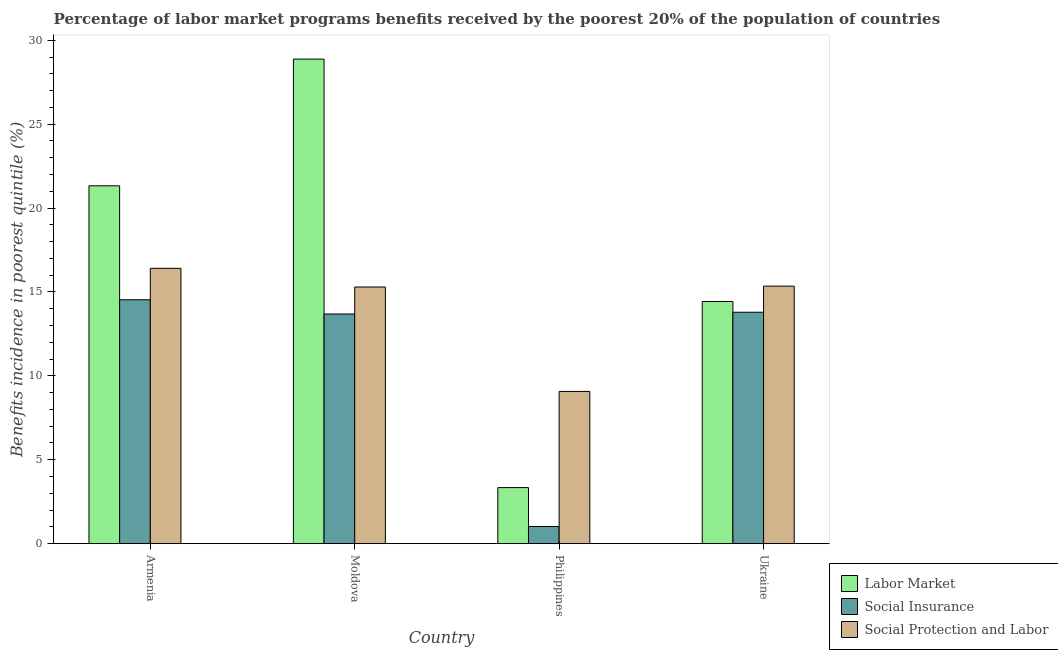How many different coloured bars are there?
Offer a very short reply. 3. How many groups of bars are there?
Your response must be concise. 4. How many bars are there on the 4th tick from the right?
Make the answer very short. 3. What is the label of the 4th group of bars from the left?
Offer a terse response. Ukraine. What is the percentage of benefits received due to social insurance programs in Ukraine?
Give a very brief answer. 13.79. Across all countries, what is the maximum percentage of benefits received due to social protection programs?
Your response must be concise. 16.41. Across all countries, what is the minimum percentage of benefits received due to labor market programs?
Keep it short and to the point. 3.34. In which country was the percentage of benefits received due to social protection programs maximum?
Your response must be concise. Armenia. In which country was the percentage of benefits received due to labor market programs minimum?
Your answer should be very brief. Philippines. What is the total percentage of benefits received due to social insurance programs in the graph?
Make the answer very short. 43.03. What is the difference between the percentage of benefits received due to social protection programs in Philippines and that in Ukraine?
Provide a short and direct response. -6.28. What is the difference between the percentage of benefits received due to labor market programs in Philippines and the percentage of benefits received due to social insurance programs in Armenia?
Give a very brief answer. -11.19. What is the average percentage of benefits received due to social insurance programs per country?
Provide a succinct answer. 10.76. What is the difference between the percentage of benefits received due to labor market programs and percentage of benefits received due to social insurance programs in Ukraine?
Your response must be concise. 0.64. What is the ratio of the percentage of benefits received due to social insurance programs in Armenia to that in Moldova?
Provide a short and direct response. 1.06. Is the percentage of benefits received due to social protection programs in Moldova less than that in Ukraine?
Offer a terse response. Yes. What is the difference between the highest and the second highest percentage of benefits received due to social protection programs?
Offer a very short reply. 1.06. What is the difference between the highest and the lowest percentage of benefits received due to labor market programs?
Ensure brevity in your answer.  25.54. In how many countries, is the percentage of benefits received due to social protection programs greater than the average percentage of benefits received due to social protection programs taken over all countries?
Your response must be concise. 3. What does the 3rd bar from the left in Armenia represents?
Offer a terse response. Social Protection and Labor. What does the 1st bar from the right in Armenia represents?
Provide a short and direct response. Social Protection and Labor. How many countries are there in the graph?
Your answer should be compact. 4. What is the difference between two consecutive major ticks on the Y-axis?
Offer a very short reply. 5. Where does the legend appear in the graph?
Provide a succinct answer. Bottom right. How are the legend labels stacked?
Give a very brief answer. Vertical. What is the title of the graph?
Your answer should be very brief. Percentage of labor market programs benefits received by the poorest 20% of the population of countries. What is the label or title of the Y-axis?
Your answer should be very brief. Benefits incidence in poorest quintile (%). What is the Benefits incidence in poorest quintile (%) of Labor Market in Armenia?
Make the answer very short. 21.33. What is the Benefits incidence in poorest quintile (%) in Social Insurance in Armenia?
Your response must be concise. 14.54. What is the Benefits incidence in poorest quintile (%) of Social Protection and Labor in Armenia?
Provide a succinct answer. 16.41. What is the Benefits incidence in poorest quintile (%) in Labor Market in Moldova?
Your response must be concise. 28.88. What is the Benefits incidence in poorest quintile (%) in Social Insurance in Moldova?
Your response must be concise. 13.69. What is the Benefits incidence in poorest quintile (%) of Social Protection and Labor in Moldova?
Offer a very short reply. 15.29. What is the Benefits incidence in poorest quintile (%) in Labor Market in Philippines?
Ensure brevity in your answer.  3.34. What is the Benefits incidence in poorest quintile (%) of Social Insurance in Philippines?
Your answer should be compact. 1.02. What is the Benefits incidence in poorest quintile (%) of Social Protection and Labor in Philippines?
Your answer should be very brief. 9.07. What is the Benefits incidence in poorest quintile (%) of Labor Market in Ukraine?
Give a very brief answer. 14.43. What is the Benefits incidence in poorest quintile (%) in Social Insurance in Ukraine?
Offer a very short reply. 13.79. What is the Benefits incidence in poorest quintile (%) of Social Protection and Labor in Ukraine?
Make the answer very short. 15.35. Across all countries, what is the maximum Benefits incidence in poorest quintile (%) in Labor Market?
Provide a short and direct response. 28.88. Across all countries, what is the maximum Benefits incidence in poorest quintile (%) in Social Insurance?
Offer a very short reply. 14.54. Across all countries, what is the maximum Benefits incidence in poorest quintile (%) of Social Protection and Labor?
Your answer should be very brief. 16.41. Across all countries, what is the minimum Benefits incidence in poorest quintile (%) in Labor Market?
Your answer should be compact. 3.34. Across all countries, what is the minimum Benefits incidence in poorest quintile (%) of Social Insurance?
Your answer should be very brief. 1.02. Across all countries, what is the minimum Benefits incidence in poorest quintile (%) of Social Protection and Labor?
Offer a very short reply. 9.07. What is the total Benefits incidence in poorest quintile (%) in Labor Market in the graph?
Give a very brief answer. 67.97. What is the total Benefits incidence in poorest quintile (%) in Social Insurance in the graph?
Provide a short and direct response. 43.03. What is the total Benefits incidence in poorest quintile (%) in Social Protection and Labor in the graph?
Give a very brief answer. 56.12. What is the difference between the Benefits incidence in poorest quintile (%) of Labor Market in Armenia and that in Moldova?
Ensure brevity in your answer.  -7.55. What is the difference between the Benefits incidence in poorest quintile (%) in Social Insurance in Armenia and that in Moldova?
Offer a very short reply. 0.85. What is the difference between the Benefits incidence in poorest quintile (%) in Social Protection and Labor in Armenia and that in Moldova?
Make the answer very short. 1.11. What is the difference between the Benefits incidence in poorest quintile (%) of Labor Market in Armenia and that in Philippines?
Offer a very short reply. 17.99. What is the difference between the Benefits incidence in poorest quintile (%) of Social Insurance in Armenia and that in Philippines?
Offer a terse response. 13.51. What is the difference between the Benefits incidence in poorest quintile (%) of Social Protection and Labor in Armenia and that in Philippines?
Provide a succinct answer. 7.34. What is the difference between the Benefits incidence in poorest quintile (%) in Labor Market in Armenia and that in Ukraine?
Your answer should be compact. 6.89. What is the difference between the Benefits incidence in poorest quintile (%) of Social Insurance in Armenia and that in Ukraine?
Keep it short and to the point. 0.74. What is the difference between the Benefits incidence in poorest quintile (%) in Social Protection and Labor in Armenia and that in Ukraine?
Offer a terse response. 1.06. What is the difference between the Benefits incidence in poorest quintile (%) of Labor Market in Moldova and that in Philippines?
Your answer should be very brief. 25.54. What is the difference between the Benefits incidence in poorest quintile (%) of Social Insurance in Moldova and that in Philippines?
Provide a succinct answer. 12.66. What is the difference between the Benefits incidence in poorest quintile (%) of Social Protection and Labor in Moldova and that in Philippines?
Your answer should be very brief. 6.22. What is the difference between the Benefits incidence in poorest quintile (%) of Labor Market in Moldova and that in Ukraine?
Provide a succinct answer. 14.44. What is the difference between the Benefits incidence in poorest quintile (%) in Social Insurance in Moldova and that in Ukraine?
Your response must be concise. -0.1. What is the difference between the Benefits incidence in poorest quintile (%) of Social Protection and Labor in Moldova and that in Ukraine?
Ensure brevity in your answer.  -0.05. What is the difference between the Benefits incidence in poorest quintile (%) of Labor Market in Philippines and that in Ukraine?
Keep it short and to the point. -11.09. What is the difference between the Benefits incidence in poorest quintile (%) of Social Insurance in Philippines and that in Ukraine?
Your answer should be compact. -12.77. What is the difference between the Benefits incidence in poorest quintile (%) in Social Protection and Labor in Philippines and that in Ukraine?
Your response must be concise. -6.28. What is the difference between the Benefits incidence in poorest quintile (%) of Labor Market in Armenia and the Benefits incidence in poorest quintile (%) of Social Insurance in Moldova?
Provide a short and direct response. 7.64. What is the difference between the Benefits incidence in poorest quintile (%) in Labor Market in Armenia and the Benefits incidence in poorest quintile (%) in Social Protection and Labor in Moldova?
Your response must be concise. 6.03. What is the difference between the Benefits incidence in poorest quintile (%) of Social Insurance in Armenia and the Benefits incidence in poorest quintile (%) of Social Protection and Labor in Moldova?
Offer a very short reply. -0.76. What is the difference between the Benefits incidence in poorest quintile (%) in Labor Market in Armenia and the Benefits incidence in poorest quintile (%) in Social Insurance in Philippines?
Provide a short and direct response. 20.3. What is the difference between the Benefits incidence in poorest quintile (%) in Labor Market in Armenia and the Benefits incidence in poorest quintile (%) in Social Protection and Labor in Philippines?
Offer a terse response. 12.25. What is the difference between the Benefits incidence in poorest quintile (%) of Social Insurance in Armenia and the Benefits incidence in poorest quintile (%) of Social Protection and Labor in Philippines?
Your response must be concise. 5.46. What is the difference between the Benefits incidence in poorest quintile (%) in Labor Market in Armenia and the Benefits incidence in poorest quintile (%) in Social Insurance in Ukraine?
Give a very brief answer. 7.53. What is the difference between the Benefits incidence in poorest quintile (%) in Labor Market in Armenia and the Benefits incidence in poorest quintile (%) in Social Protection and Labor in Ukraine?
Keep it short and to the point. 5.98. What is the difference between the Benefits incidence in poorest quintile (%) in Social Insurance in Armenia and the Benefits incidence in poorest quintile (%) in Social Protection and Labor in Ukraine?
Give a very brief answer. -0.81. What is the difference between the Benefits incidence in poorest quintile (%) of Labor Market in Moldova and the Benefits incidence in poorest quintile (%) of Social Insurance in Philippines?
Ensure brevity in your answer.  27.85. What is the difference between the Benefits incidence in poorest quintile (%) of Labor Market in Moldova and the Benefits incidence in poorest quintile (%) of Social Protection and Labor in Philippines?
Your response must be concise. 19.8. What is the difference between the Benefits incidence in poorest quintile (%) in Social Insurance in Moldova and the Benefits incidence in poorest quintile (%) in Social Protection and Labor in Philippines?
Your answer should be very brief. 4.62. What is the difference between the Benefits incidence in poorest quintile (%) of Labor Market in Moldova and the Benefits incidence in poorest quintile (%) of Social Insurance in Ukraine?
Ensure brevity in your answer.  15.09. What is the difference between the Benefits incidence in poorest quintile (%) of Labor Market in Moldova and the Benefits incidence in poorest quintile (%) of Social Protection and Labor in Ukraine?
Provide a succinct answer. 13.53. What is the difference between the Benefits incidence in poorest quintile (%) of Social Insurance in Moldova and the Benefits incidence in poorest quintile (%) of Social Protection and Labor in Ukraine?
Offer a terse response. -1.66. What is the difference between the Benefits incidence in poorest quintile (%) of Labor Market in Philippines and the Benefits incidence in poorest quintile (%) of Social Insurance in Ukraine?
Keep it short and to the point. -10.45. What is the difference between the Benefits incidence in poorest quintile (%) in Labor Market in Philippines and the Benefits incidence in poorest quintile (%) in Social Protection and Labor in Ukraine?
Provide a succinct answer. -12.01. What is the difference between the Benefits incidence in poorest quintile (%) of Social Insurance in Philippines and the Benefits incidence in poorest quintile (%) of Social Protection and Labor in Ukraine?
Offer a very short reply. -14.32. What is the average Benefits incidence in poorest quintile (%) of Labor Market per country?
Your answer should be compact. 16.99. What is the average Benefits incidence in poorest quintile (%) in Social Insurance per country?
Your response must be concise. 10.76. What is the average Benefits incidence in poorest quintile (%) in Social Protection and Labor per country?
Your response must be concise. 14.03. What is the difference between the Benefits incidence in poorest quintile (%) in Labor Market and Benefits incidence in poorest quintile (%) in Social Insurance in Armenia?
Your answer should be very brief. 6.79. What is the difference between the Benefits incidence in poorest quintile (%) of Labor Market and Benefits incidence in poorest quintile (%) of Social Protection and Labor in Armenia?
Provide a succinct answer. 4.92. What is the difference between the Benefits incidence in poorest quintile (%) in Social Insurance and Benefits incidence in poorest quintile (%) in Social Protection and Labor in Armenia?
Give a very brief answer. -1.87. What is the difference between the Benefits incidence in poorest quintile (%) of Labor Market and Benefits incidence in poorest quintile (%) of Social Insurance in Moldova?
Offer a very short reply. 15.19. What is the difference between the Benefits incidence in poorest quintile (%) in Labor Market and Benefits incidence in poorest quintile (%) in Social Protection and Labor in Moldova?
Your answer should be very brief. 13.58. What is the difference between the Benefits incidence in poorest quintile (%) in Social Insurance and Benefits incidence in poorest quintile (%) in Social Protection and Labor in Moldova?
Your answer should be compact. -1.61. What is the difference between the Benefits incidence in poorest quintile (%) in Labor Market and Benefits incidence in poorest quintile (%) in Social Insurance in Philippines?
Make the answer very short. 2.32. What is the difference between the Benefits incidence in poorest quintile (%) in Labor Market and Benefits incidence in poorest quintile (%) in Social Protection and Labor in Philippines?
Your response must be concise. -5.73. What is the difference between the Benefits incidence in poorest quintile (%) in Social Insurance and Benefits incidence in poorest quintile (%) in Social Protection and Labor in Philippines?
Your answer should be very brief. -8.05. What is the difference between the Benefits incidence in poorest quintile (%) of Labor Market and Benefits incidence in poorest quintile (%) of Social Insurance in Ukraine?
Make the answer very short. 0.64. What is the difference between the Benefits incidence in poorest quintile (%) in Labor Market and Benefits incidence in poorest quintile (%) in Social Protection and Labor in Ukraine?
Provide a succinct answer. -0.91. What is the difference between the Benefits incidence in poorest quintile (%) of Social Insurance and Benefits incidence in poorest quintile (%) of Social Protection and Labor in Ukraine?
Offer a terse response. -1.56. What is the ratio of the Benefits incidence in poorest quintile (%) in Labor Market in Armenia to that in Moldova?
Your answer should be compact. 0.74. What is the ratio of the Benefits incidence in poorest quintile (%) of Social Insurance in Armenia to that in Moldova?
Provide a short and direct response. 1.06. What is the ratio of the Benefits incidence in poorest quintile (%) in Social Protection and Labor in Armenia to that in Moldova?
Make the answer very short. 1.07. What is the ratio of the Benefits incidence in poorest quintile (%) of Labor Market in Armenia to that in Philippines?
Provide a succinct answer. 6.38. What is the ratio of the Benefits incidence in poorest quintile (%) of Social Insurance in Armenia to that in Philippines?
Ensure brevity in your answer.  14.22. What is the ratio of the Benefits incidence in poorest quintile (%) of Social Protection and Labor in Armenia to that in Philippines?
Ensure brevity in your answer.  1.81. What is the ratio of the Benefits incidence in poorest quintile (%) in Labor Market in Armenia to that in Ukraine?
Your answer should be very brief. 1.48. What is the ratio of the Benefits incidence in poorest quintile (%) in Social Insurance in Armenia to that in Ukraine?
Offer a terse response. 1.05. What is the ratio of the Benefits incidence in poorest quintile (%) of Social Protection and Labor in Armenia to that in Ukraine?
Keep it short and to the point. 1.07. What is the ratio of the Benefits incidence in poorest quintile (%) of Labor Market in Moldova to that in Philippines?
Provide a succinct answer. 8.64. What is the ratio of the Benefits incidence in poorest quintile (%) in Social Insurance in Moldova to that in Philippines?
Offer a very short reply. 13.39. What is the ratio of the Benefits incidence in poorest quintile (%) of Social Protection and Labor in Moldova to that in Philippines?
Make the answer very short. 1.69. What is the ratio of the Benefits incidence in poorest quintile (%) in Labor Market in Moldova to that in Ukraine?
Offer a very short reply. 2. What is the ratio of the Benefits incidence in poorest quintile (%) of Social Insurance in Moldova to that in Ukraine?
Offer a very short reply. 0.99. What is the ratio of the Benefits incidence in poorest quintile (%) of Social Protection and Labor in Moldova to that in Ukraine?
Offer a very short reply. 1. What is the ratio of the Benefits incidence in poorest quintile (%) of Labor Market in Philippines to that in Ukraine?
Keep it short and to the point. 0.23. What is the ratio of the Benefits incidence in poorest quintile (%) of Social Insurance in Philippines to that in Ukraine?
Give a very brief answer. 0.07. What is the ratio of the Benefits incidence in poorest quintile (%) in Social Protection and Labor in Philippines to that in Ukraine?
Keep it short and to the point. 0.59. What is the difference between the highest and the second highest Benefits incidence in poorest quintile (%) in Labor Market?
Provide a short and direct response. 7.55. What is the difference between the highest and the second highest Benefits incidence in poorest quintile (%) of Social Insurance?
Your response must be concise. 0.74. What is the difference between the highest and the second highest Benefits incidence in poorest quintile (%) of Social Protection and Labor?
Give a very brief answer. 1.06. What is the difference between the highest and the lowest Benefits incidence in poorest quintile (%) of Labor Market?
Offer a terse response. 25.54. What is the difference between the highest and the lowest Benefits incidence in poorest quintile (%) in Social Insurance?
Offer a very short reply. 13.51. What is the difference between the highest and the lowest Benefits incidence in poorest quintile (%) of Social Protection and Labor?
Make the answer very short. 7.34. 